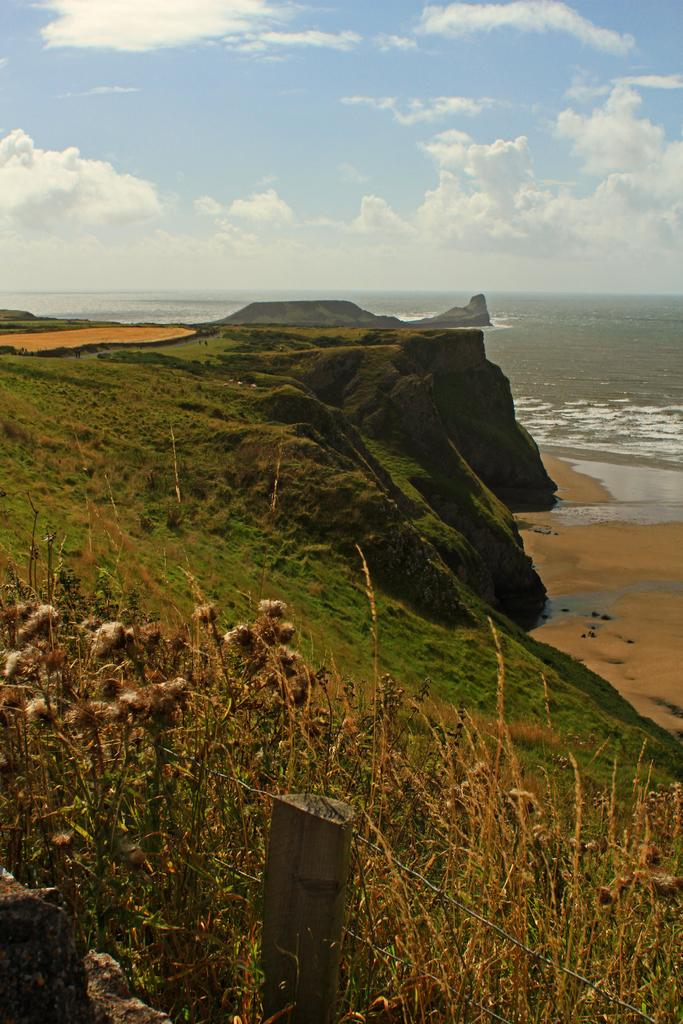What type of landscape is depicted in the image? The image features hills and water. What can be found at the bottom of the image? There are plants and a fence at the bottom of the image. What is visible in the background of the image? The sky is visible in the background of the image. What type of appliance can be seen in the image? There is no appliance present in the image. What sense is being stimulated by the plants in the image? The image is visual, so no specific sense is being stimulated by the plants. 